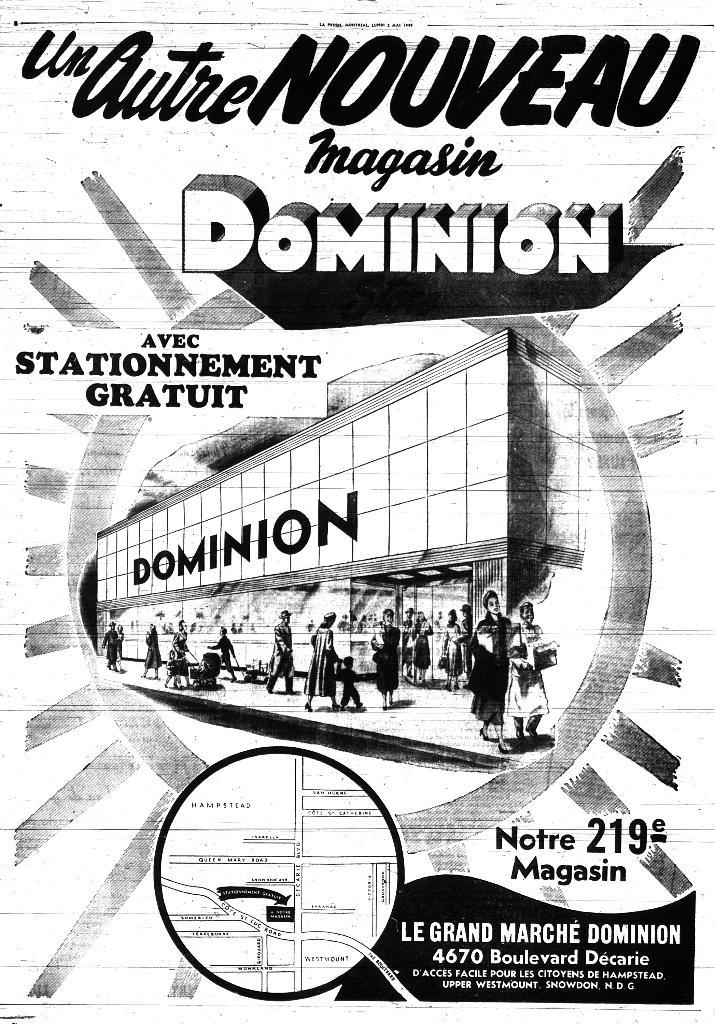<image>
Share a concise interpretation of the image provided. A poster has the word "DOMINION" in big letters. 